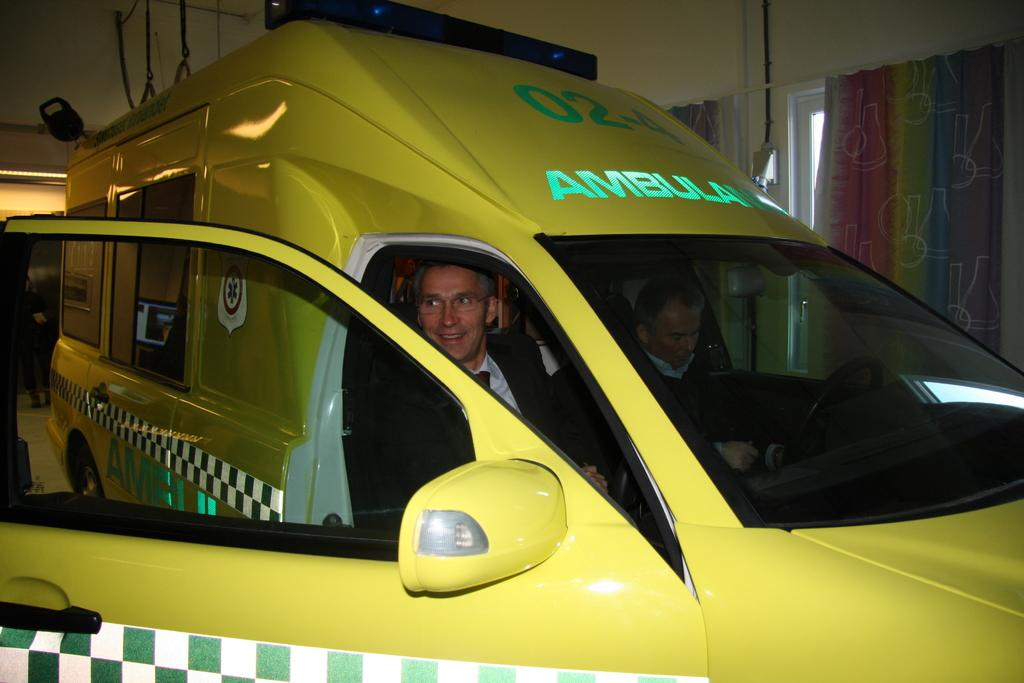Provide a one-sentence caption for the provided image. A man in a yellow ambulance is smiling out of an open door. 